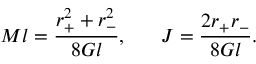Convert formula to latex. <formula><loc_0><loc_0><loc_500><loc_500>M l = { \frac { r _ { + } ^ { 2 } + r _ { - } ^ { 2 } } { 8 G l } } , \quad \ J = { \frac { 2 r _ { + } r _ { - } } { 8 G l } } .</formula> 